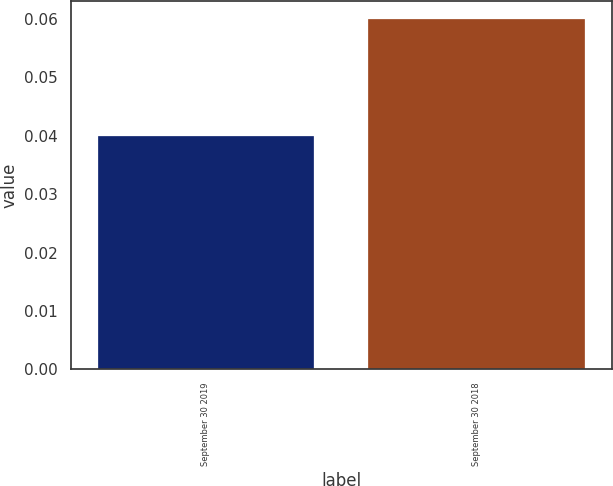Convert chart. <chart><loc_0><loc_0><loc_500><loc_500><bar_chart><fcel>September 30 2019<fcel>September 30 2018<nl><fcel>0.04<fcel>0.06<nl></chart> 